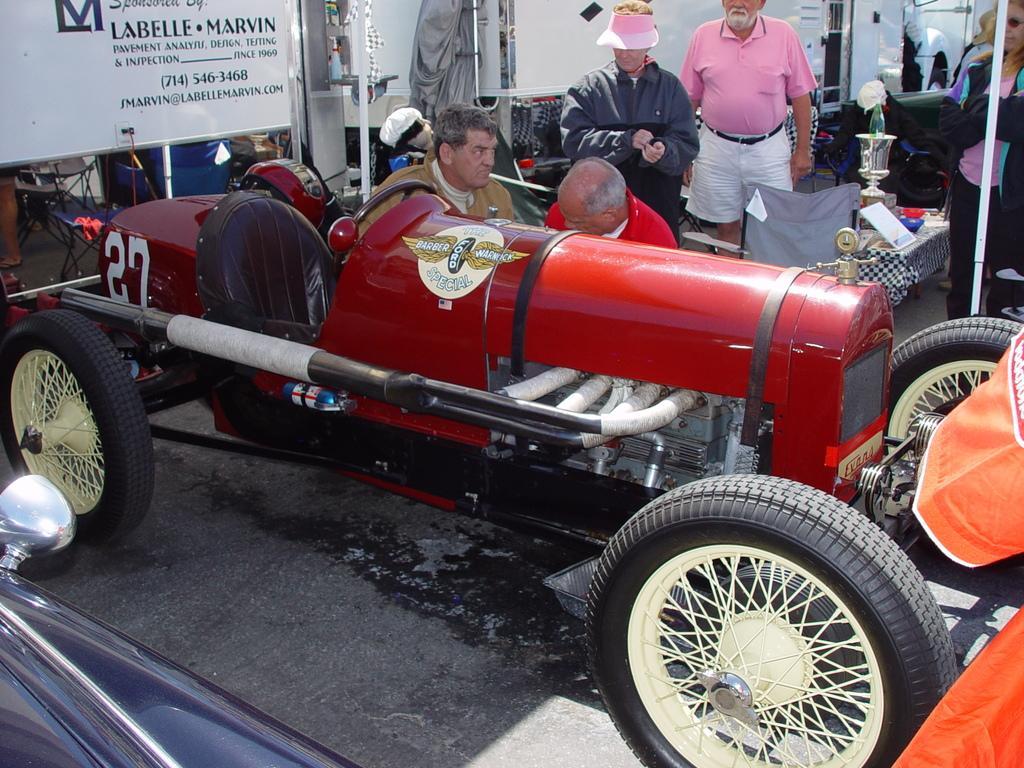Can you describe this image briefly? In the background we can see white boards and few people standing. Here we can see men sitting near to a red color vehicle. On a table we can see a board and other objects. 